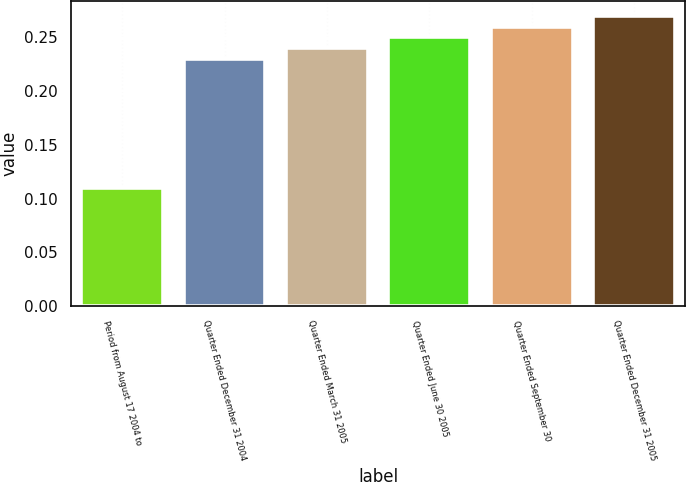Convert chart. <chart><loc_0><loc_0><loc_500><loc_500><bar_chart><fcel>Period from August 17 2004 to<fcel>Quarter Ended December 31 2004<fcel>Quarter Ended March 31 2005<fcel>Quarter Ended June 30 2005<fcel>Quarter Ended September 30<fcel>Quarter Ended December 31 2005<nl><fcel>0.11<fcel>0.23<fcel>0.24<fcel>0.25<fcel>0.26<fcel>0.27<nl></chart> 